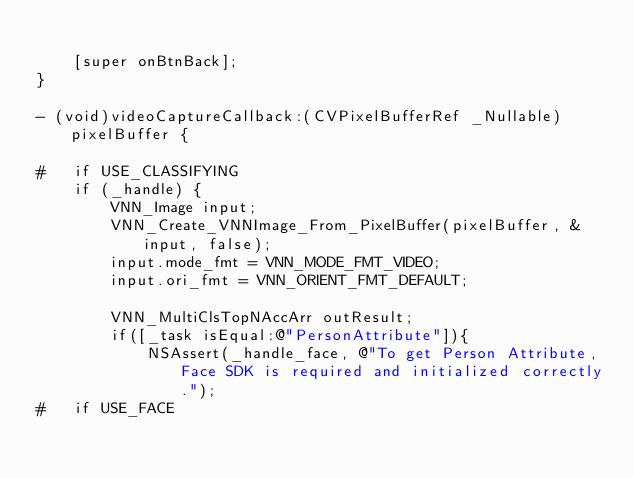Convert code to text. <code><loc_0><loc_0><loc_500><loc_500><_ObjectiveC_>    
    [super onBtnBack];
}

- (void)videoCaptureCallback:(CVPixelBufferRef _Nullable)pixelBuffer {
    
#   if USE_CLASSIFYING
    if (_handle) {
        VNN_Image input;
        VNN_Create_VNNImage_From_PixelBuffer(pixelBuffer, &input, false);
        input.mode_fmt = VNN_MODE_FMT_VIDEO;
        input.ori_fmt = VNN_ORIENT_FMT_DEFAULT;
        
        VNN_MultiClsTopNAccArr outResult;
        if([_task isEqual:@"PersonAttribute"]){
            NSAssert(_handle_face, @"To get Person Attribute, Face SDK is required and initialized correctly.");
#   if USE_FACE</code> 